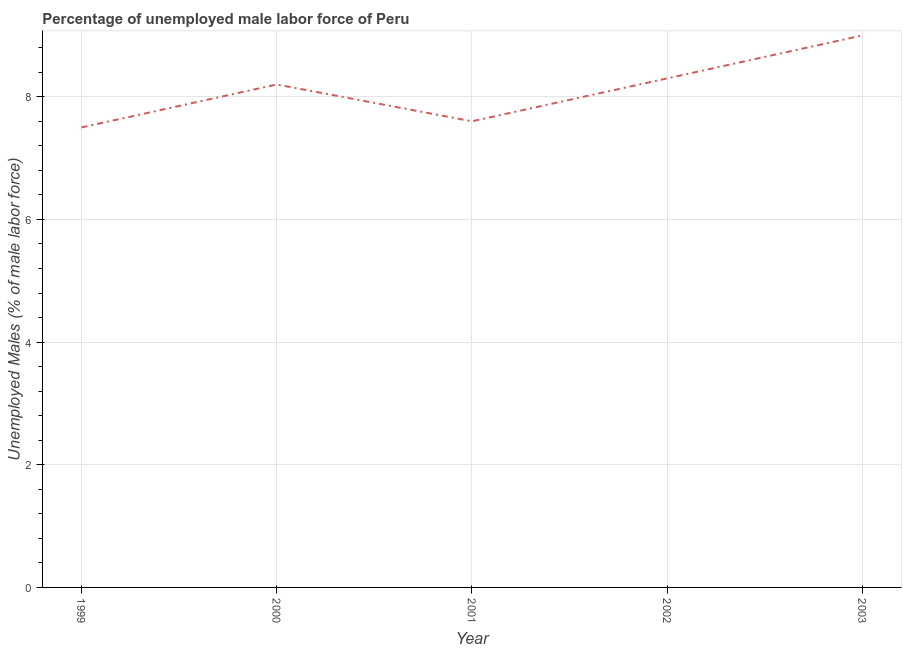What is the total unemployed male labour force in 2002?
Provide a succinct answer. 8.3. Across all years, what is the maximum total unemployed male labour force?
Your answer should be compact. 9. Across all years, what is the minimum total unemployed male labour force?
Ensure brevity in your answer.  7.5. In which year was the total unemployed male labour force maximum?
Your response must be concise. 2003. What is the sum of the total unemployed male labour force?
Offer a terse response. 40.6. What is the difference between the total unemployed male labour force in 2002 and 2003?
Provide a short and direct response. -0.7. What is the average total unemployed male labour force per year?
Provide a short and direct response. 8.12. What is the median total unemployed male labour force?
Provide a succinct answer. 8.2. Do a majority of the years between 2001 and 1999 (inclusive) have total unemployed male labour force greater than 5.6 %?
Make the answer very short. No. What is the ratio of the total unemployed male labour force in 2001 to that in 2003?
Offer a very short reply. 0.84. Is the total unemployed male labour force in 2000 less than that in 2002?
Provide a short and direct response. Yes. Is the difference between the total unemployed male labour force in 2001 and 2003 greater than the difference between any two years?
Your answer should be very brief. No. What is the difference between the highest and the second highest total unemployed male labour force?
Ensure brevity in your answer.  0.7. Is the sum of the total unemployed male labour force in 2000 and 2002 greater than the maximum total unemployed male labour force across all years?
Make the answer very short. Yes. Does the total unemployed male labour force monotonically increase over the years?
Your response must be concise. No. How many lines are there?
Keep it short and to the point. 1. How many years are there in the graph?
Your answer should be compact. 5. Are the values on the major ticks of Y-axis written in scientific E-notation?
Give a very brief answer. No. What is the title of the graph?
Offer a terse response. Percentage of unemployed male labor force of Peru. What is the label or title of the X-axis?
Offer a very short reply. Year. What is the label or title of the Y-axis?
Your answer should be very brief. Unemployed Males (% of male labor force). What is the Unemployed Males (% of male labor force) of 2000?
Your answer should be very brief. 8.2. What is the Unemployed Males (% of male labor force) of 2001?
Offer a very short reply. 7.6. What is the Unemployed Males (% of male labor force) in 2002?
Give a very brief answer. 8.3. What is the difference between the Unemployed Males (% of male labor force) in 1999 and 2000?
Your answer should be very brief. -0.7. What is the difference between the Unemployed Males (% of male labor force) in 1999 and 2001?
Offer a terse response. -0.1. What is the difference between the Unemployed Males (% of male labor force) in 1999 and 2002?
Your answer should be very brief. -0.8. What is the difference between the Unemployed Males (% of male labor force) in 1999 and 2003?
Your response must be concise. -1.5. What is the difference between the Unemployed Males (% of male labor force) in 2000 and 2002?
Your answer should be very brief. -0.1. What is the difference between the Unemployed Males (% of male labor force) in 2001 and 2002?
Your response must be concise. -0.7. What is the difference between the Unemployed Males (% of male labor force) in 2001 and 2003?
Make the answer very short. -1.4. What is the ratio of the Unemployed Males (% of male labor force) in 1999 to that in 2000?
Give a very brief answer. 0.92. What is the ratio of the Unemployed Males (% of male labor force) in 1999 to that in 2001?
Your answer should be very brief. 0.99. What is the ratio of the Unemployed Males (% of male labor force) in 1999 to that in 2002?
Provide a succinct answer. 0.9. What is the ratio of the Unemployed Males (% of male labor force) in 1999 to that in 2003?
Provide a short and direct response. 0.83. What is the ratio of the Unemployed Males (% of male labor force) in 2000 to that in 2001?
Offer a very short reply. 1.08. What is the ratio of the Unemployed Males (% of male labor force) in 2000 to that in 2003?
Keep it short and to the point. 0.91. What is the ratio of the Unemployed Males (% of male labor force) in 2001 to that in 2002?
Your response must be concise. 0.92. What is the ratio of the Unemployed Males (% of male labor force) in 2001 to that in 2003?
Your answer should be compact. 0.84. What is the ratio of the Unemployed Males (% of male labor force) in 2002 to that in 2003?
Your answer should be very brief. 0.92. 